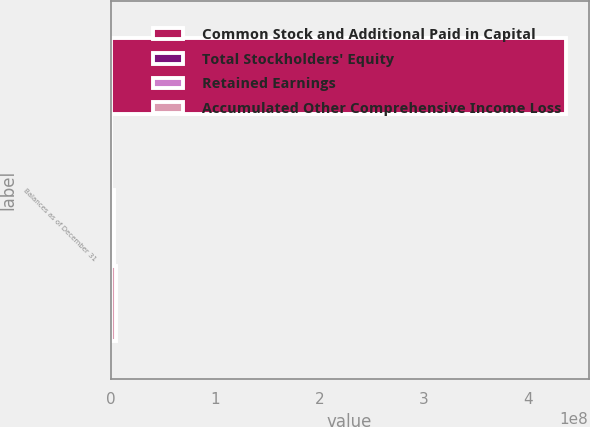<chart> <loc_0><loc_0><loc_500><loc_500><stacked_bar_chart><ecel><fcel>Balances as of December 31<nl><fcel>Common Stock and Additional Paid in Capital<fcel>4.36599e+08<nl><fcel>Total Stockholders' Equity<fcel>19582<nl><fcel>Retained Earnings<fcel>2.94236e+06<nl><fcel>Accumulated Other Comprehensive Income Loss<fcel>5.23876e+06<nl></chart> 